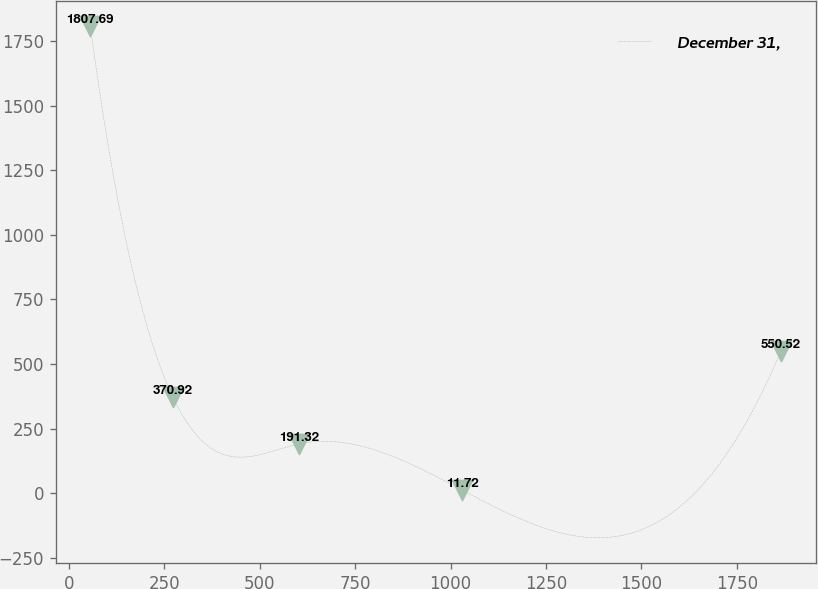Convert chart. <chart><loc_0><loc_0><loc_500><loc_500><line_chart><ecel><fcel>December 31,<nl><fcel>55.55<fcel>1807.69<nl><fcel>272.46<fcel>370.92<nl><fcel>603.28<fcel>191.32<nl><fcel>1030.84<fcel>11.72<nl><fcel>1866.04<fcel>550.52<nl></chart> 